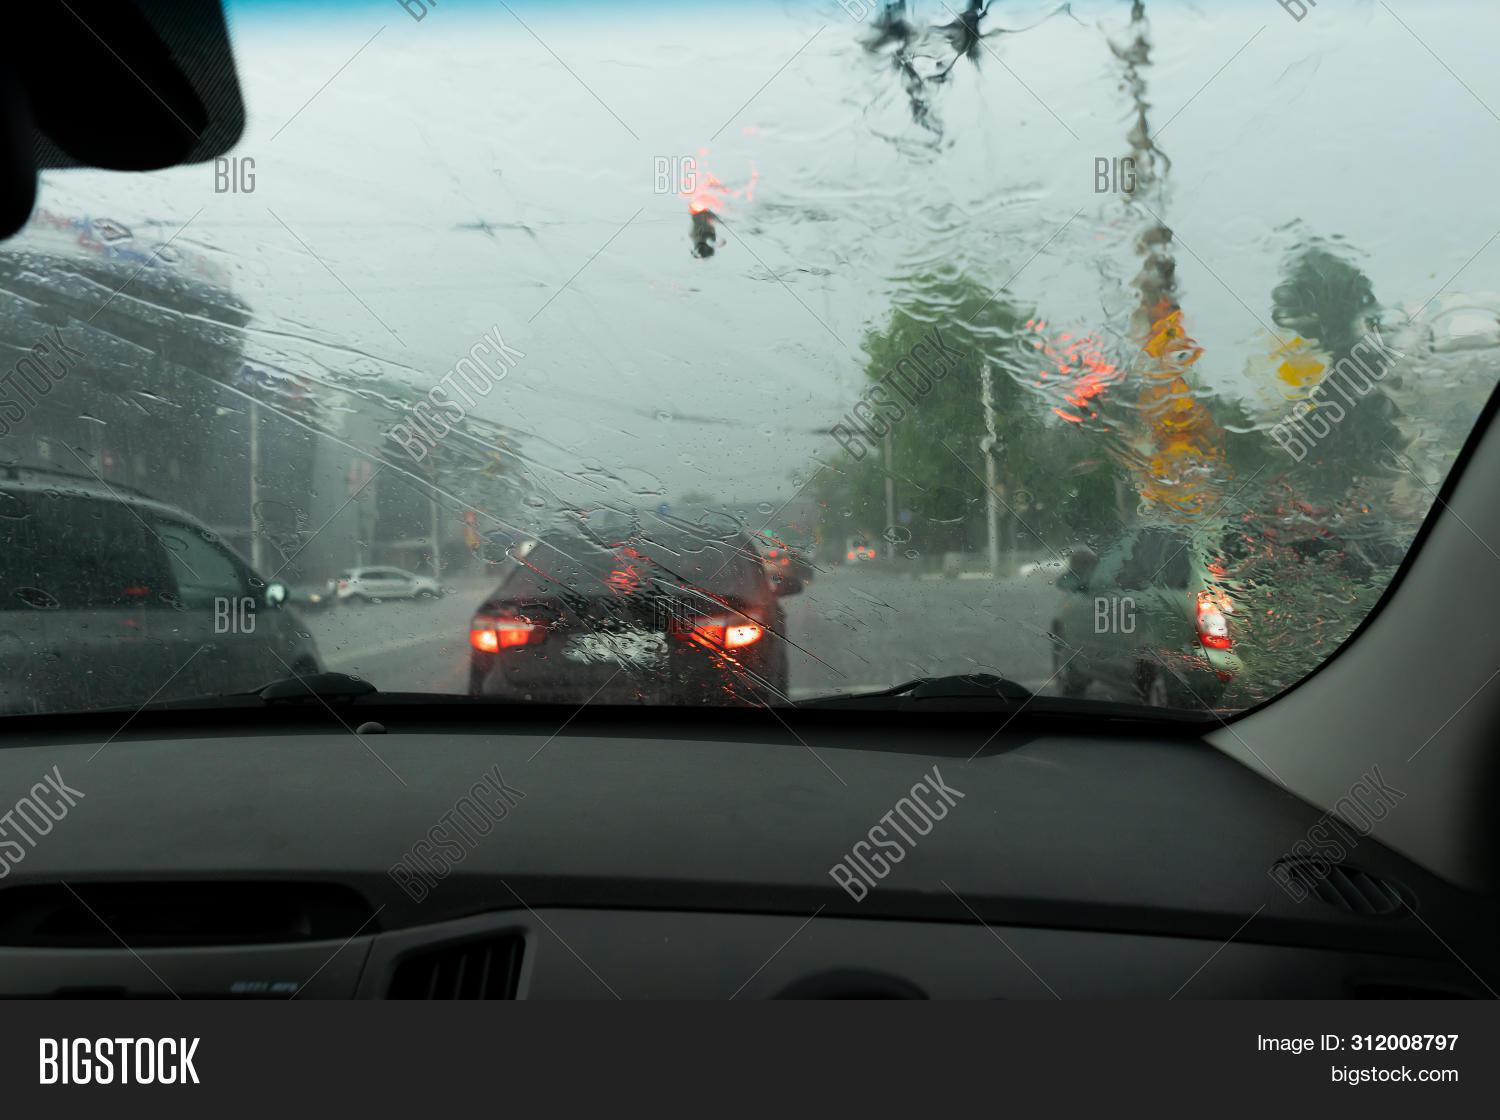Can you describe the weather conditions outside? The weather appears to be quite rainy and possibly stormy, as indicated by the heavy raindrops streaking across the windshield and the gray, overcast sky that can be glimpsed between the droplets. 